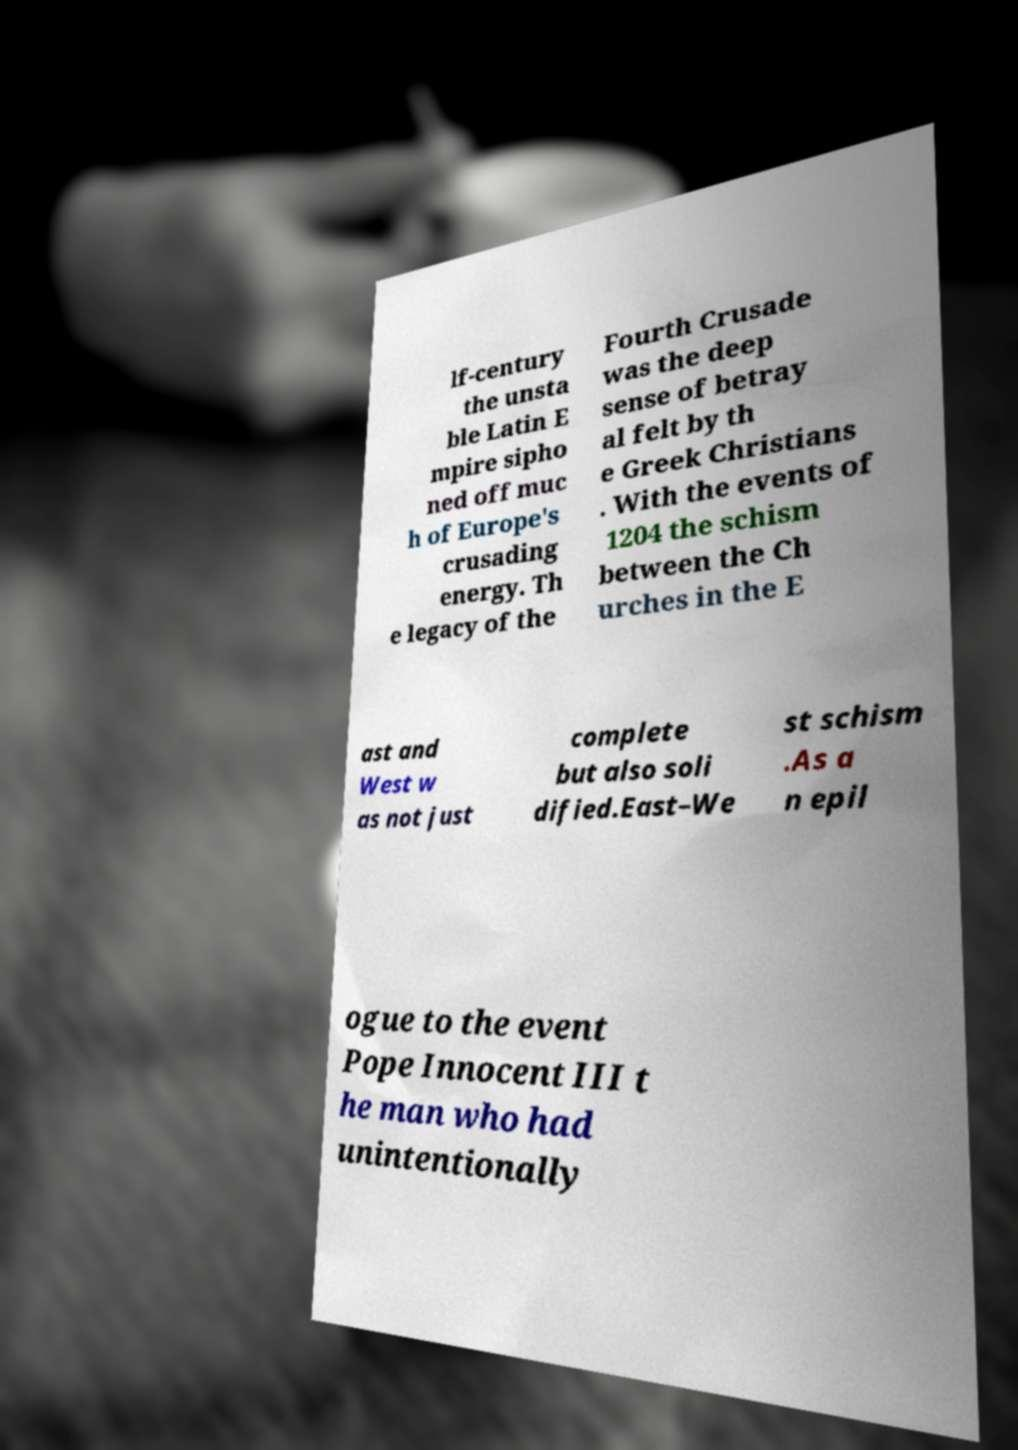Could you extract and type out the text from this image? lf-century the unsta ble Latin E mpire sipho ned off muc h of Europe's crusading energy. Th e legacy of the Fourth Crusade was the deep sense of betray al felt by th e Greek Christians . With the events of 1204 the schism between the Ch urches in the E ast and West w as not just complete but also soli dified.East–We st schism .As a n epil ogue to the event Pope Innocent III t he man who had unintentionally 